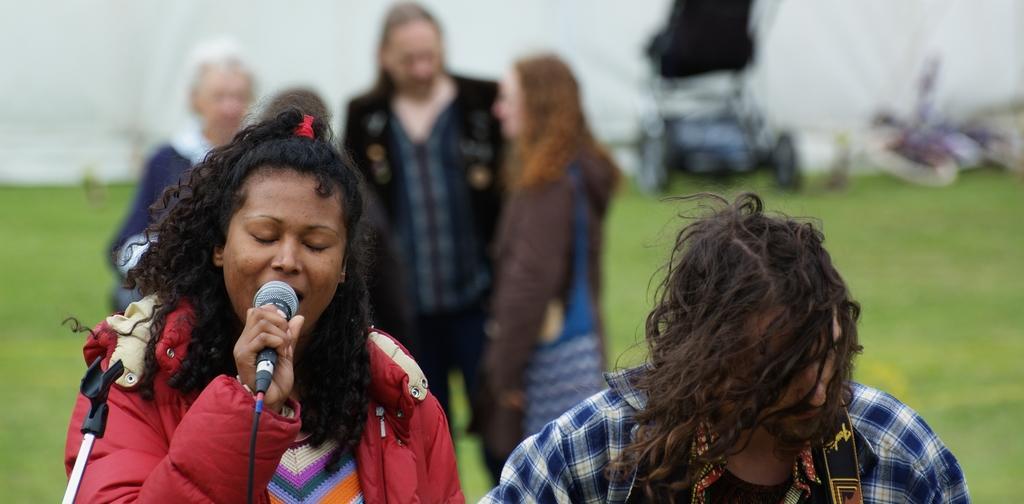Describe this image in one or two sentences. In this image there are two person's, a person holding a mike, mike stand, and at the background there are three people standing, grass. 